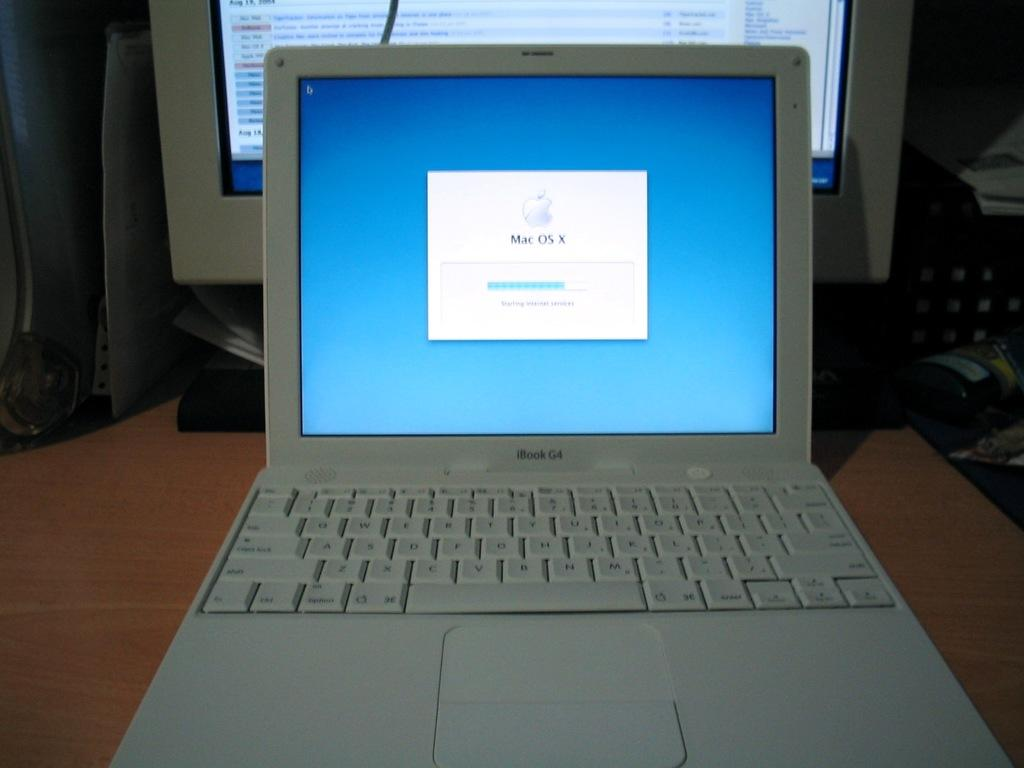Provide a one-sentence caption for the provided image. An iBook G4 laptop is open to show a blue screen and the Mac OS X operating system logo. 